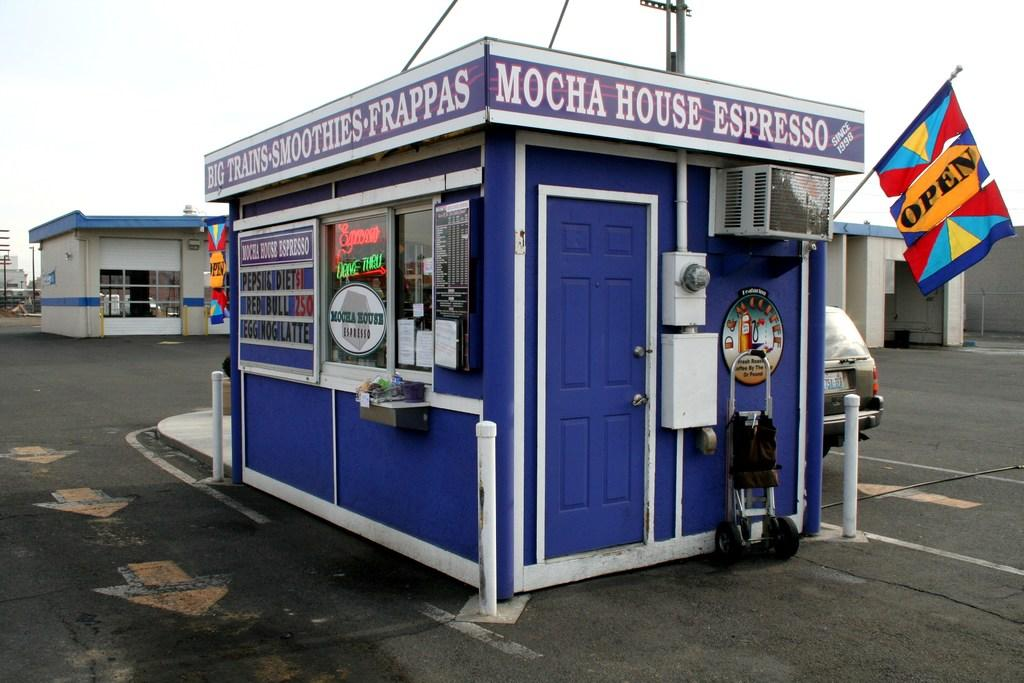What is located in the foreground of the image? There is a food stall, a flag, and a car on the road in the foreground of the image. What can be seen in the background of the image? The sky is visible in the background of the image. When was the image taken? The image was taken during the day. What type of design can be seen on the table in the image? There is no table present in the image, so it is not possible to answer that question. 